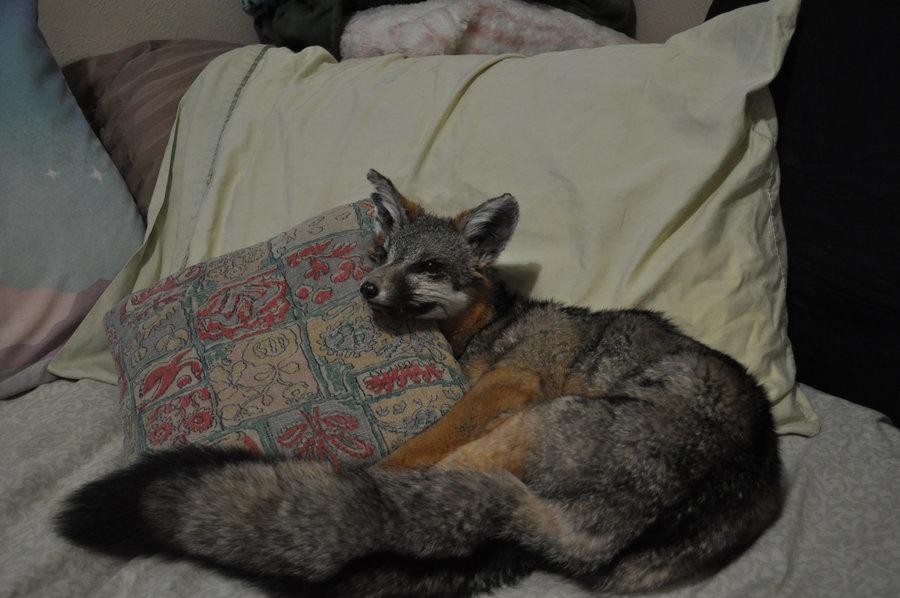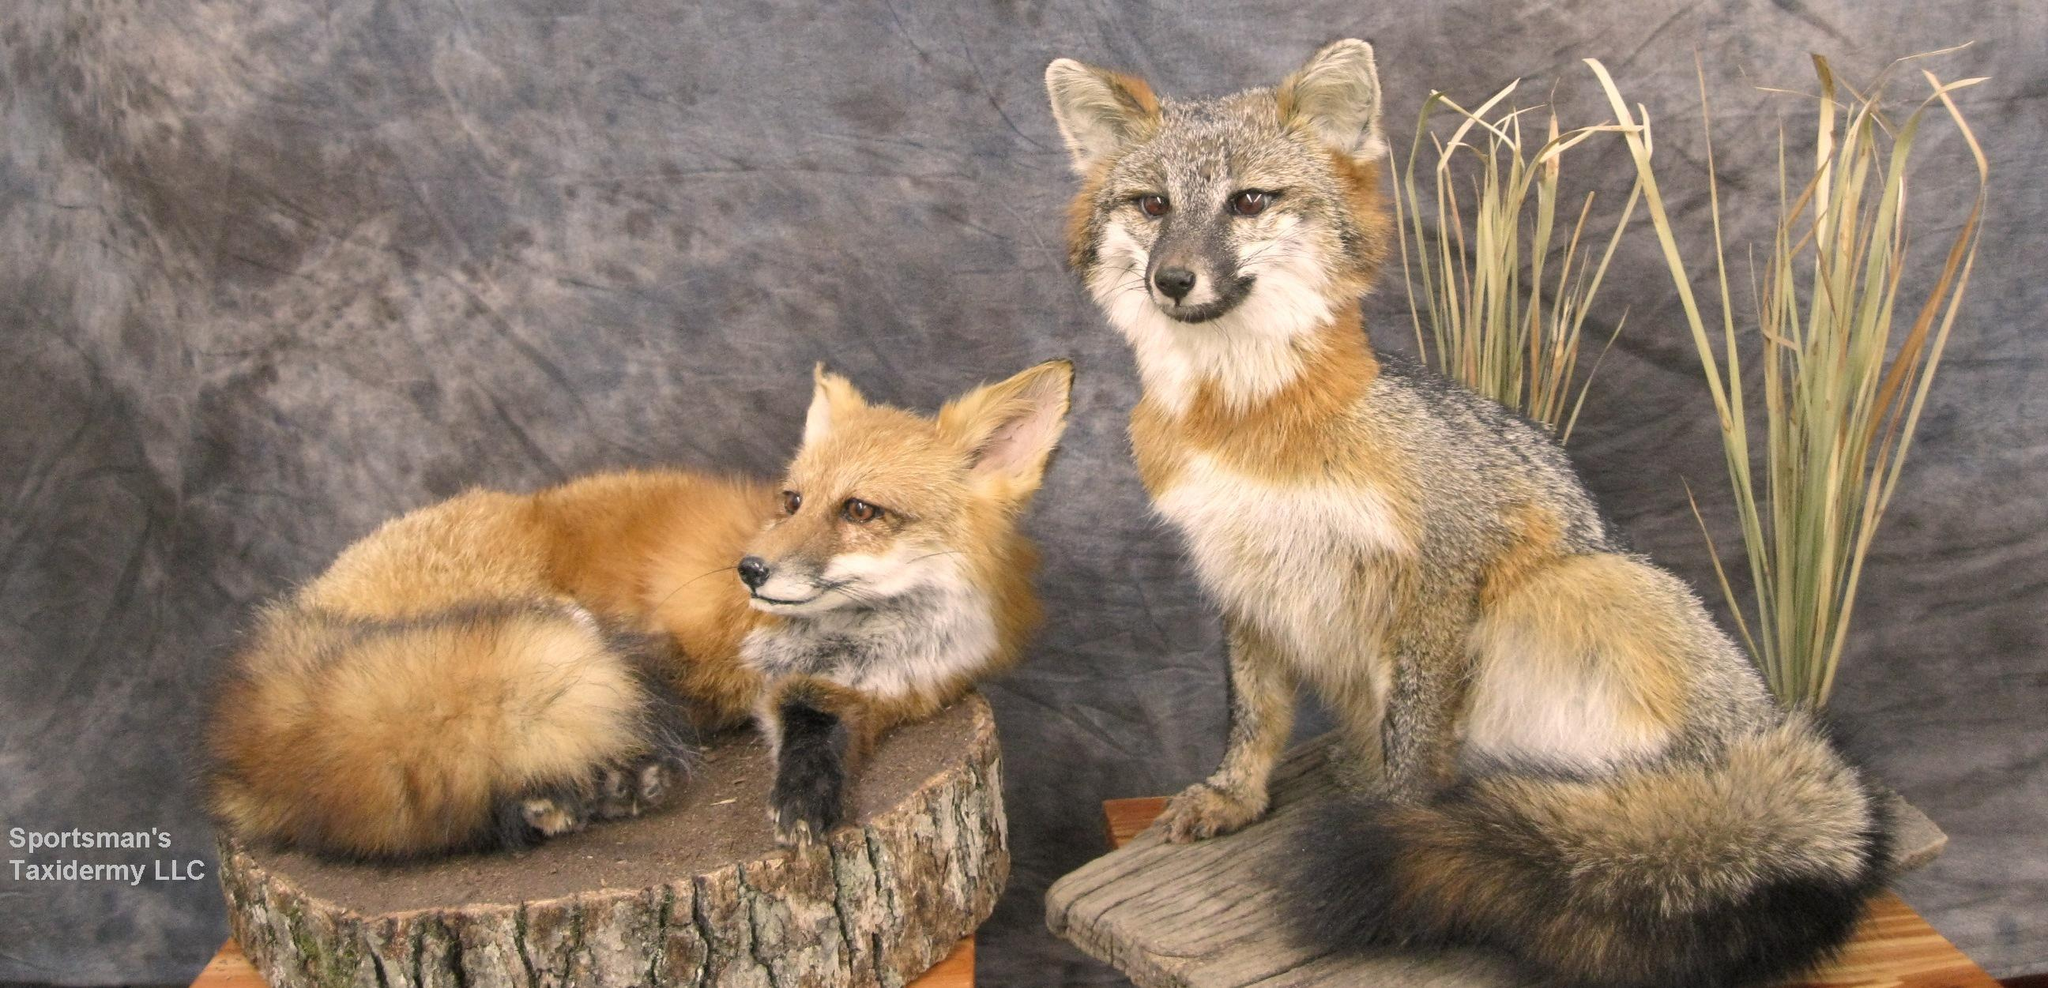The first image is the image on the left, the second image is the image on the right. Given the left and right images, does the statement "The left image features one fox in a curled resting pose, and the right image features two foxes, with one reclining on the flat surface of a cut log section." hold true? Answer yes or no. Yes. The first image is the image on the left, the second image is the image on the right. Examine the images to the left and right. Is the description "There are two foxes in the image to the right, and one in the other image." accurate? Answer yes or no. Yes. 